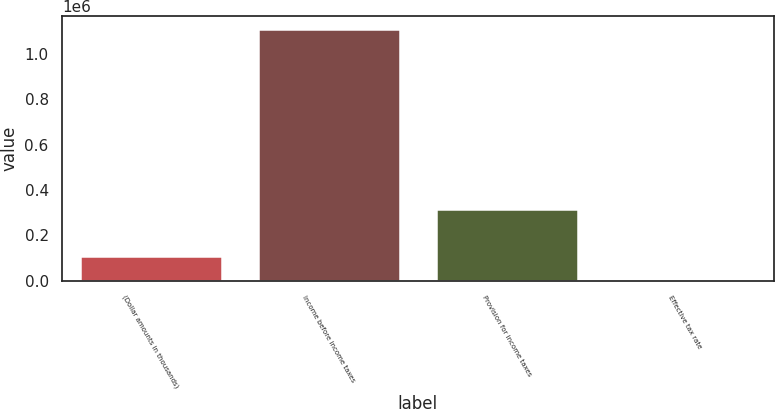Convert chart. <chart><loc_0><loc_0><loc_500><loc_500><bar_chart><fcel>(Dollar amounts in thousands)<fcel>Income before income taxes<fcel>Provision for income taxes<fcel>Effective tax rate<nl><fcel>111032<fcel>1.11007e+06<fcel>315578<fcel>28.4<nl></chart> 